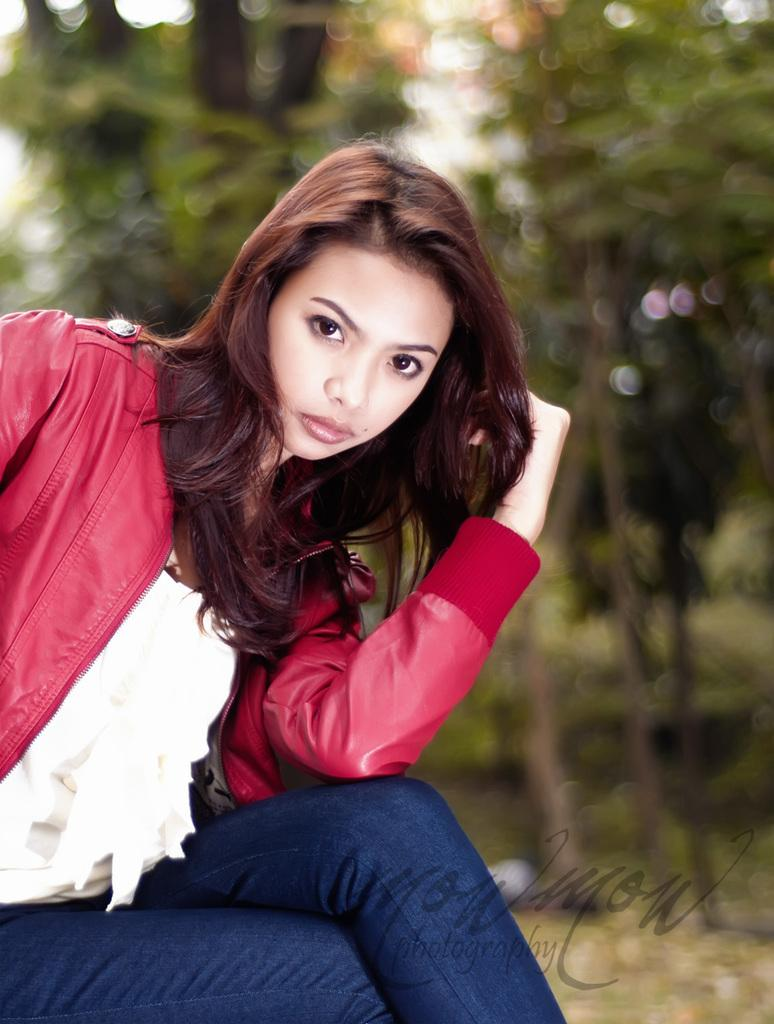Who is the main subject in the image? There is a girl in the image. Where is the girl located in the image? The girl is on the left side of the image. What is the girl wearing in the image? The girl is wearing a coat and trousers. What can be seen in the background of the image? There are trees in the background of the image. Is there any additional information about the image itself? Yes, there is a watermark at the bottom of the image. What type of camp can be seen in the image? There is no camp present in the image; it features a girl on the left side of the image wearing a coat and trousers, with trees in the background and a watermark at the bottom. 